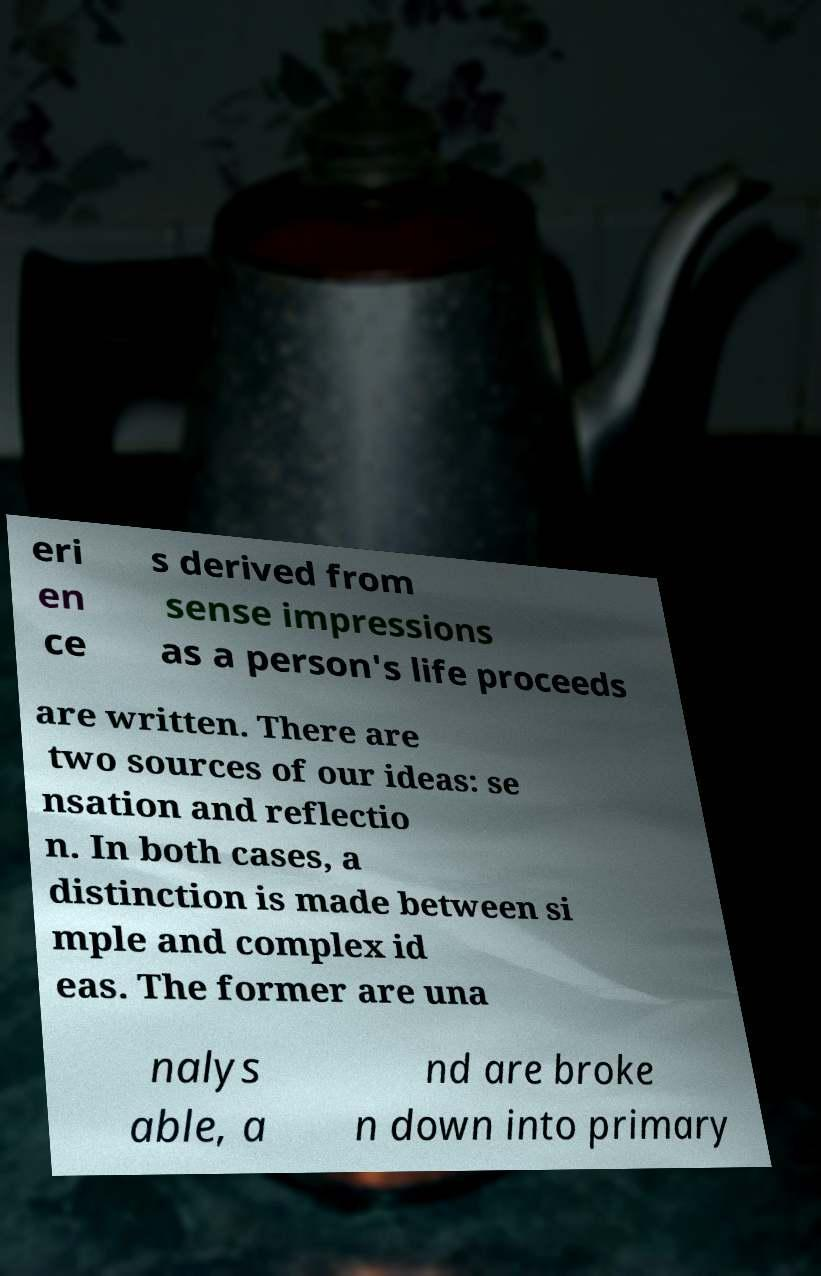I need the written content from this picture converted into text. Can you do that? eri en ce s derived from sense impressions as a person's life proceeds are written. There are two sources of our ideas: se nsation and reflectio n. In both cases, a distinction is made between si mple and complex id eas. The former are una nalys able, a nd are broke n down into primary 